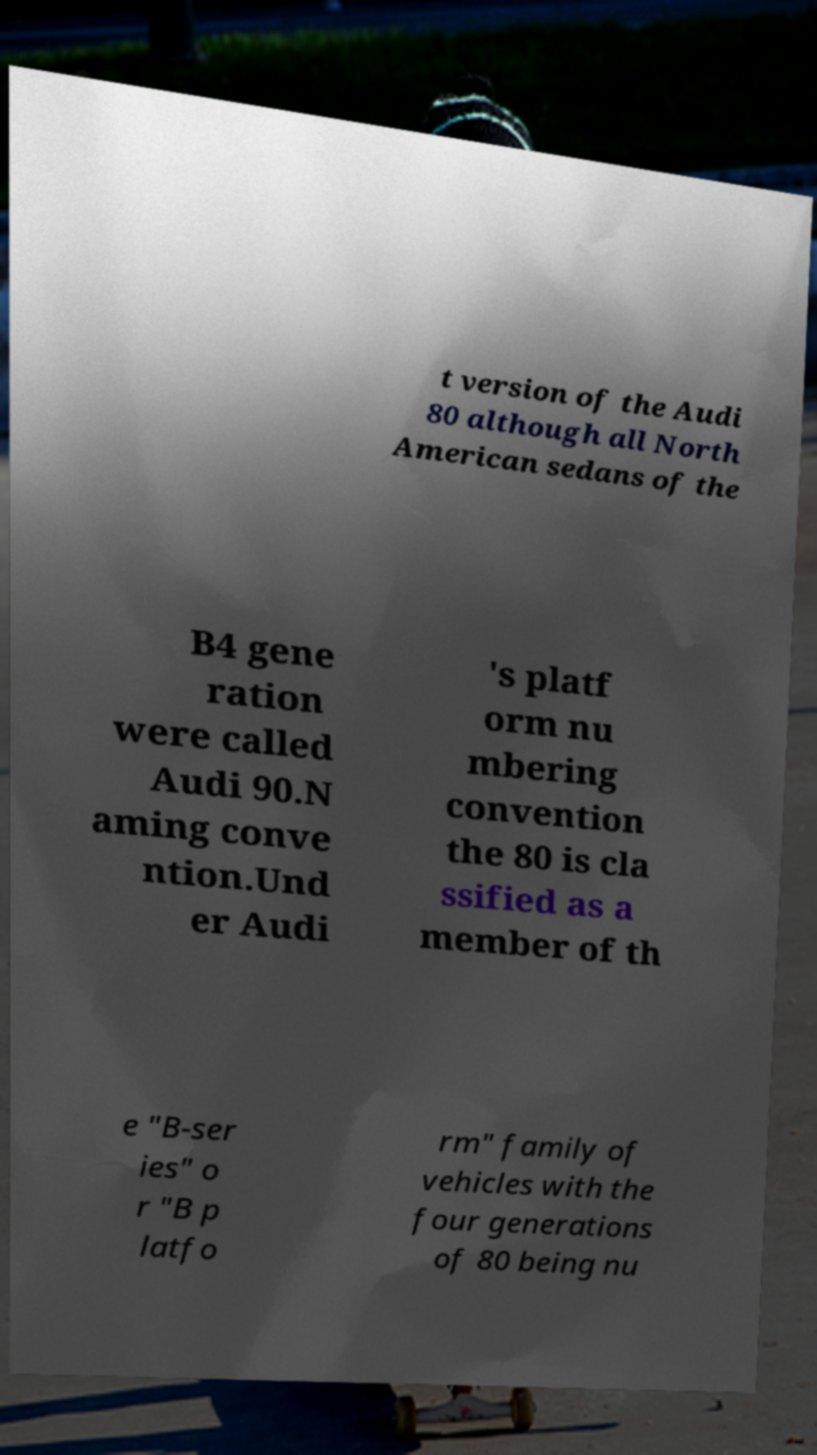What messages or text are displayed in this image? I need them in a readable, typed format. t version of the Audi 80 although all North American sedans of the B4 gene ration were called Audi 90.N aming conve ntion.Und er Audi 's platf orm nu mbering convention the 80 is cla ssified as a member of th e "B-ser ies" o r "B p latfo rm" family of vehicles with the four generations of 80 being nu 